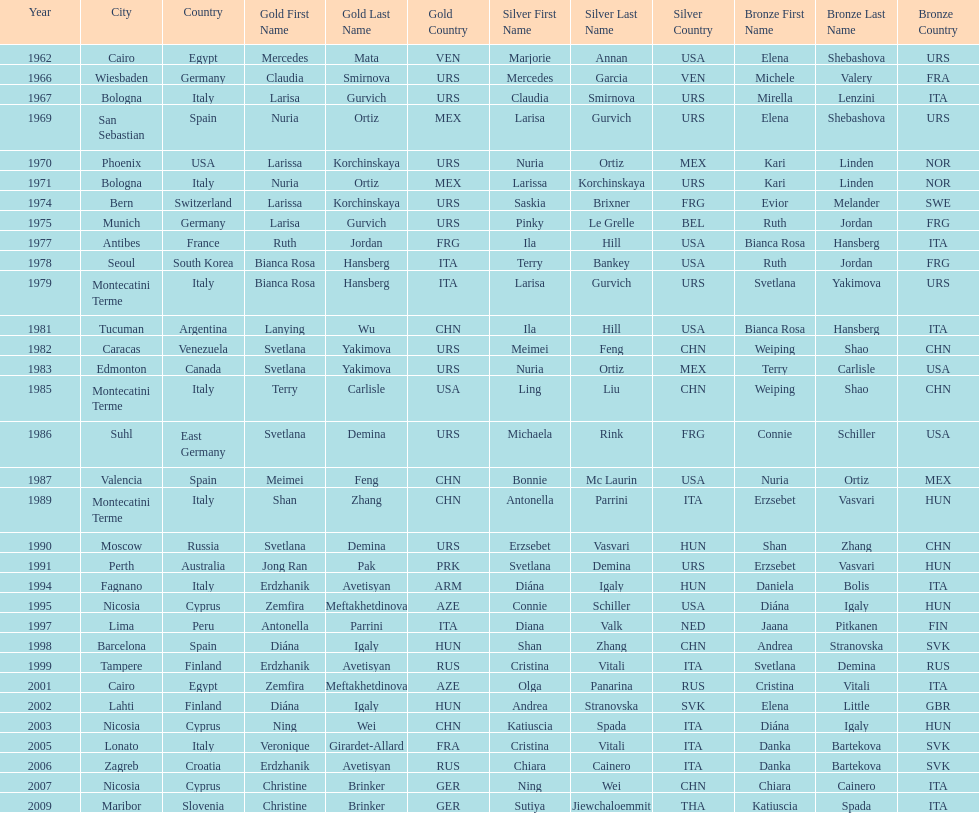What is the total of silver for cairo 0. 